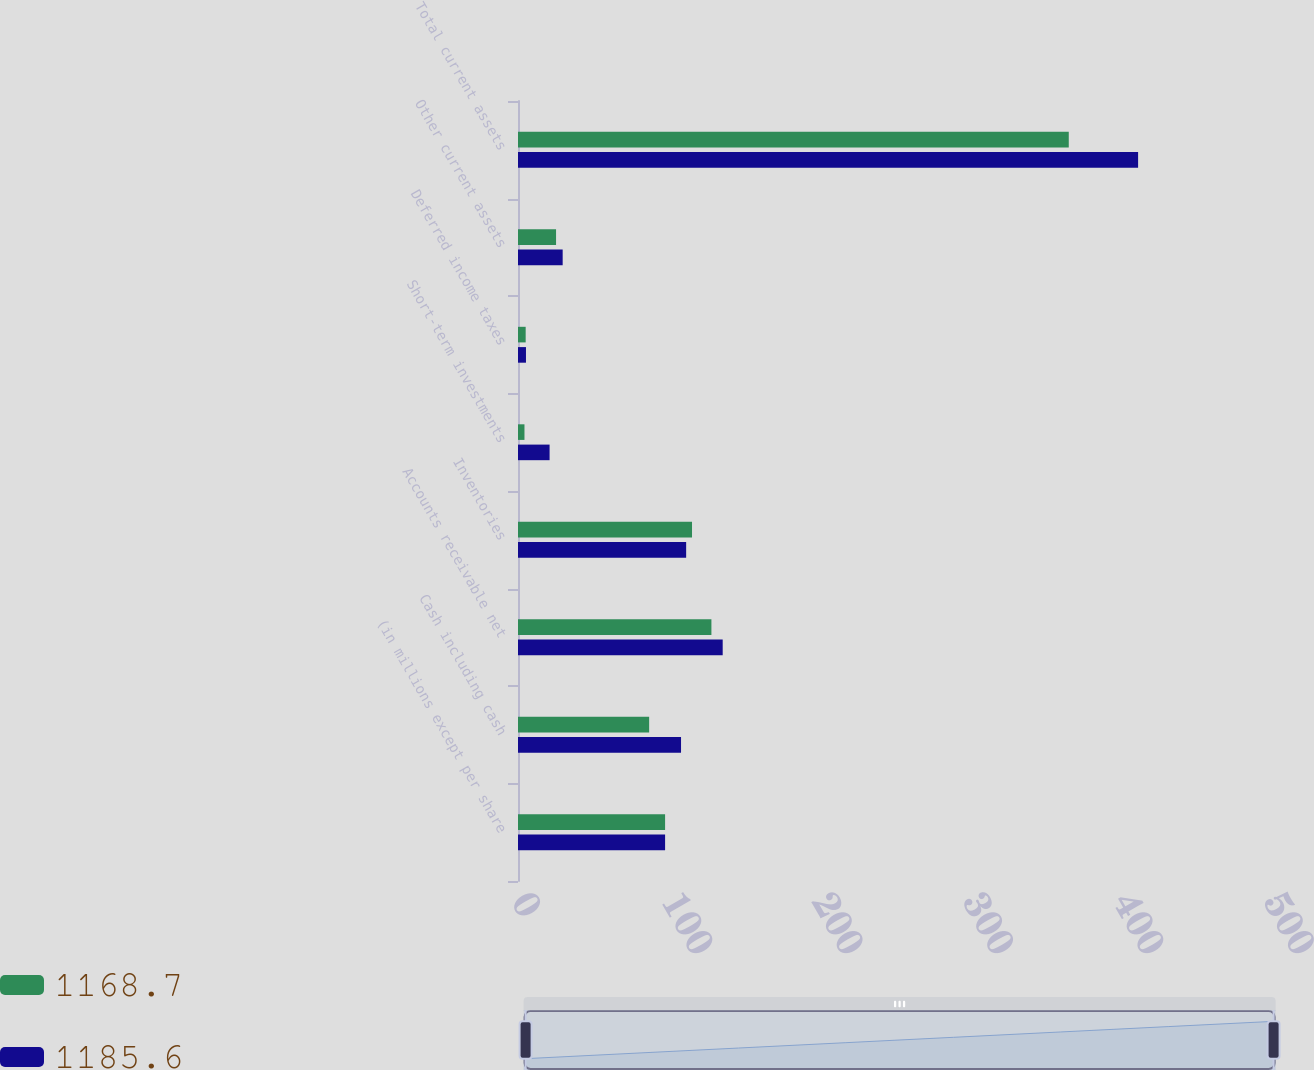Convert chart to OTSL. <chart><loc_0><loc_0><loc_500><loc_500><stacked_bar_chart><ecel><fcel>(in millions except per share<fcel>Cash including cash<fcel>Accounts receivable net<fcel>Inventories<fcel>Short-term investments<fcel>Deferred income taxes<fcel>Other current assets<fcel>Total current assets<nl><fcel>1168.7<fcel>97.8<fcel>87.2<fcel>128.6<fcel>115.7<fcel>4.3<fcel>5.1<fcel>25.3<fcel>366.2<nl><fcel>1185.6<fcel>97.8<fcel>108.4<fcel>136.1<fcel>111.8<fcel>21<fcel>5.3<fcel>29.7<fcel>412.3<nl></chart> 